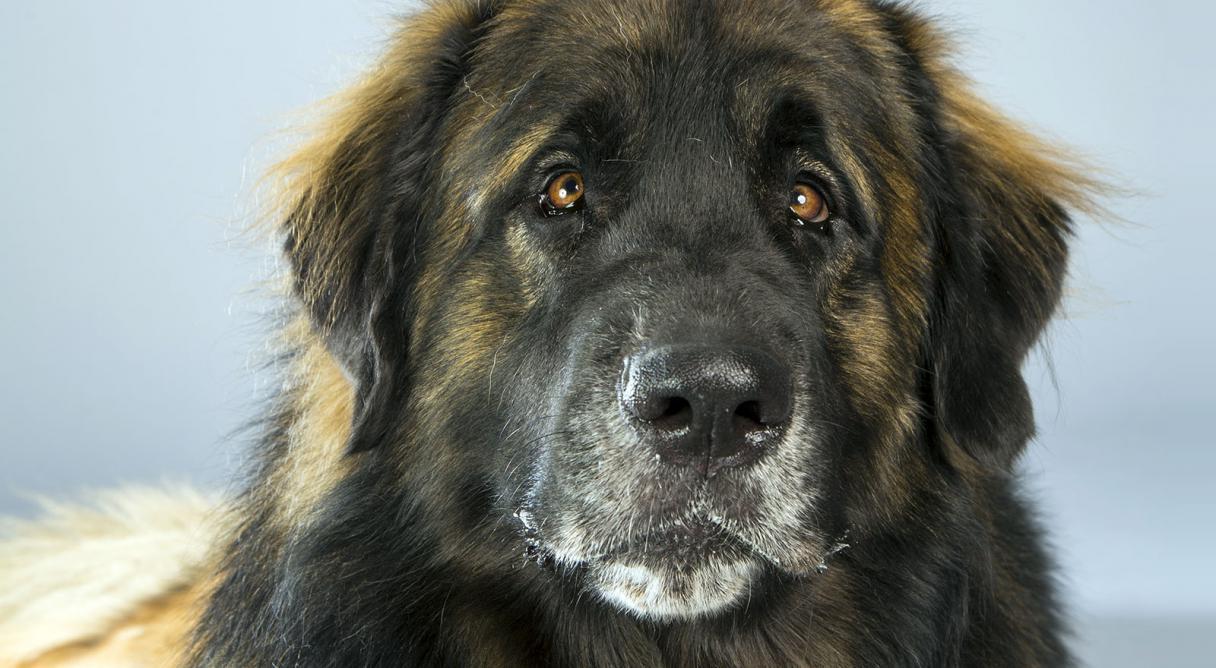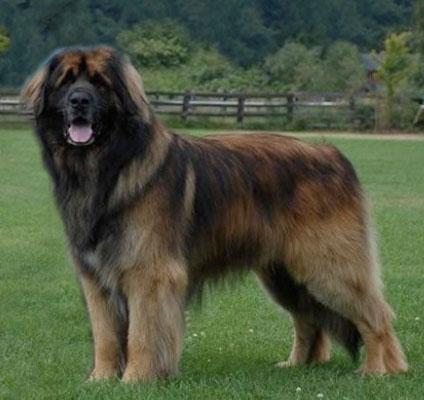The first image is the image on the left, the second image is the image on the right. For the images shown, is this caption "There are three dogs." true? Answer yes or no. No. 